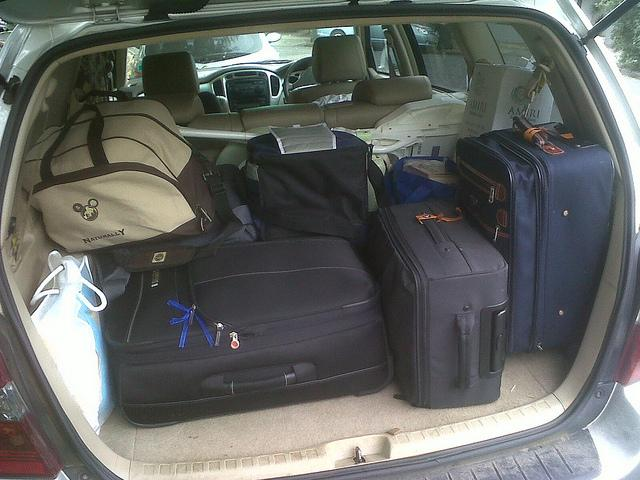Why would this person load the back of their car with these? Please explain your reasoning. road trip. The person is on a road trip. 